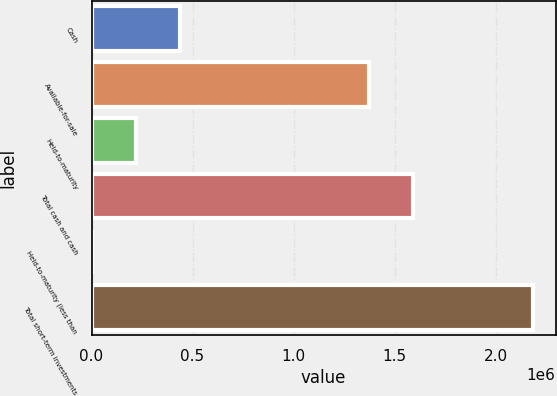<chart> <loc_0><loc_0><loc_500><loc_500><bar_chart><fcel>Cash<fcel>Available-for-sale<fcel>Held-to-maturity<fcel>Total cash and cash<fcel>Held-to-maturity (less than<fcel>Total short-term investments<nl><fcel>437936<fcel>1.37407e+06<fcel>219258<fcel>1.59275e+06<fcel>580<fcel>2.18736e+06<nl></chart> 